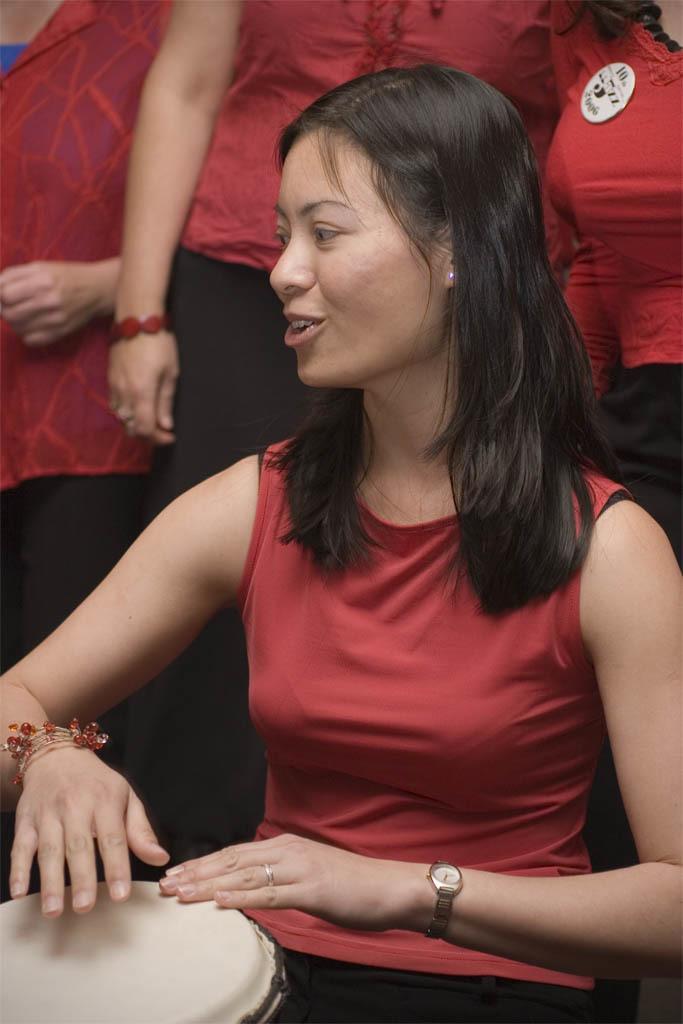Please provide a concise description of this image. A woman is sitting and playing drum behind her there are few people. 